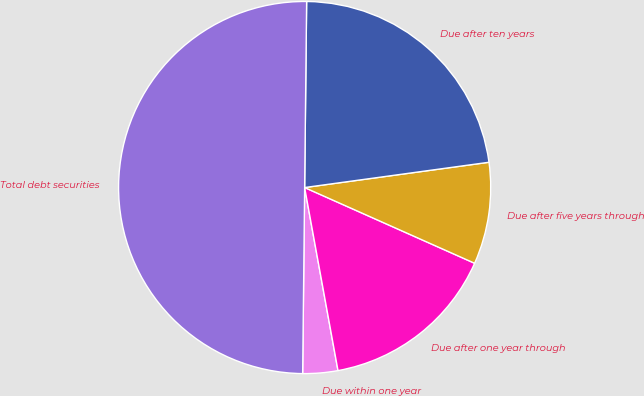Convert chart. <chart><loc_0><loc_0><loc_500><loc_500><pie_chart><fcel>Due within one year<fcel>Due after one year through<fcel>Due after five years through<fcel>Due after ten years<fcel>Total debt securities<nl><fcel>3.04%<fcel>15.46%<fcel>8.84%<fcel>22.66%<fcel>50.0%<nl></chart> 